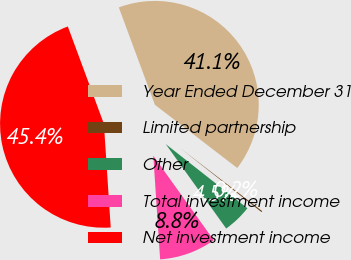<chart> <loc_0><loc_0><loc_500><loc_500><pie_chart><fcel>Year Ended December 31<fcel>Limited partnership<fcel>Other<fcel>Total investment income<fcel>Net investment income<nl><fcel>41.06%<fcel>0.18%<fcel>4.51%<fcel>8.84%<fcel>45.39%<nl></chart> 